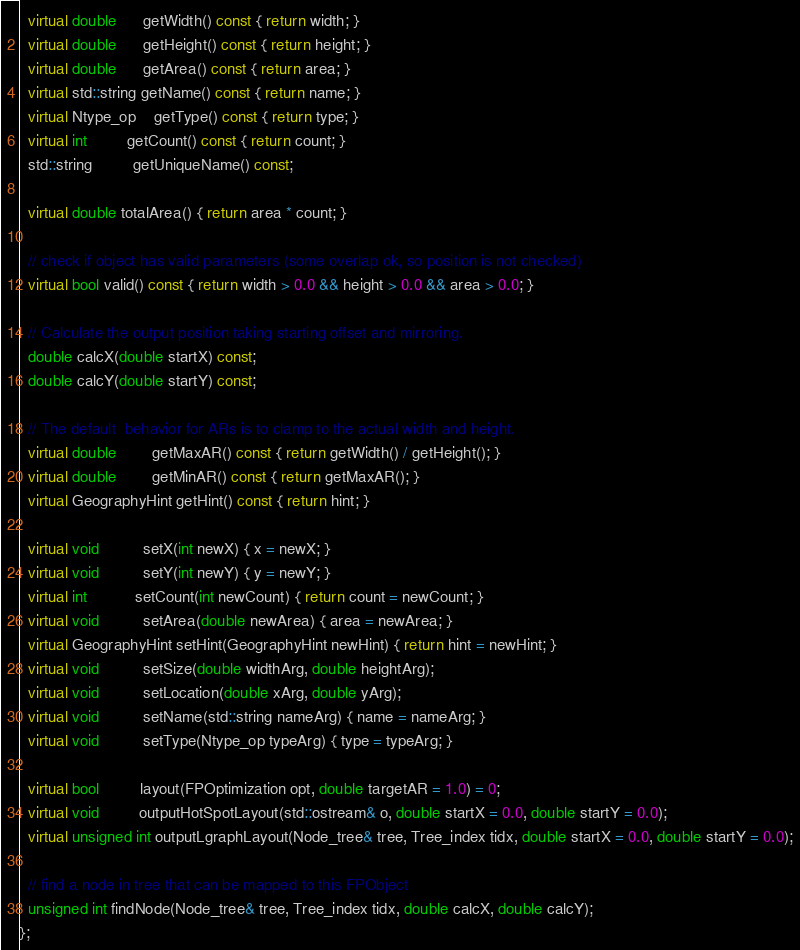Convert code to text. <code><loc_0><loc_0><loc_500><loc_500><_C++_>  virtual double      getWidth() const { return width; }
  virtual double      getHeight() const { return height; }
  virtual double      getArea() const { return area; }
  virtual std::string getName() const { return name; }
  virtual Ntype_op    getType() const { return type; }
  virtual int         getCount() const { return count; }
  std::string         getUniqueName() const;

  virtual double totalArea() { return area * count; }

  // check if object has valid parameters (some overlap ok, so position is not checked)
  virtual bool valid() const { return width > 0.0 && height > 0.0 && area > 0.0; }

  // Calculate the output position taking starting offset and mirroring.
  double calcX(double startX) const;
  double calcY(double startY) const;

  // The default  behavior for ARs is to clamp to the actual width and height.
  virtual double        getMaxAR() const { return getWidth() / getHeight(); }
  virtual double        getMinAR() const { return getMaxAR(); }
  virtual GeographyHint getHint() const { return hint; }

  virtual void          setX(int newX) { x = newX; }
  virtual void          setY(int newY) { y = newY; }
  virtual int           setCount(int newCount) { return count = newCount; }
  virtual void          setArea(double newArea) { area = newArea; }
  virtual GeographyHint setHint(GeographyHint newHint) { return hint = newHint; }
  virtual void          setSize(double widthArg, double heightArg);
  virtual void          setLocation(double xArg, double yArg);
  virtual void          setName(std::string nameArg) { name = nameArg; }
  virtual void          setType(Ntype_op typeArg) { type = typeArg; }

  virtual bool         layout(FPOptimization opt, double targetAR = 1.0) = 0;
  virtual void         outputHotSpotLayout(std::ostream& o, double startX = 0.0, double startY = 0.0);
  virtual unsigned int outputLgraphLayout(Node_tree& tree, Tree_index tidx, double startX = 0.0, double startY = 0.0);

  // find a node in tree that can be mapped to this FPObject
  unsigned int findNode(Node_tree& tree, Tree_index tidx, double calcX, double calcY);
};</code> 